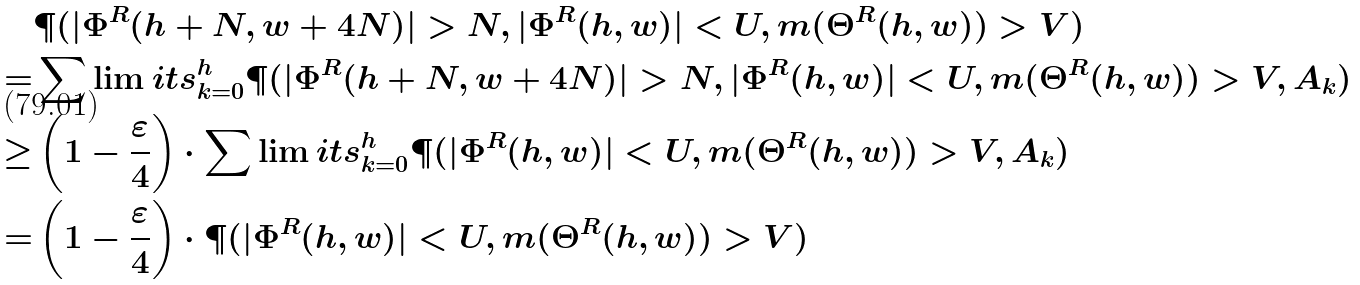<formula> <loc_0><loc_0><loc_500><loc_500>& \P ( | \Phi ^ { R } ( h + N , w + 4 N ) | > N , | \Phi ^ { R } ( h , w ) | < U , m ( \Theta ^ { R } ( h , w ) ) > V ) \\ = & \sum \lim i t s _ { k = 0 } ^ { h } \P ( | \Phi ^ { R } ( h + N , w + 4 N ) | > N , | \Phi ^ { R } ( h , w ) | < U , m ( \Theta ^ { R } ( h , w ) ) > V , A _ { k } ) \\ \geq & \left ( 1 - \frac { \varepsilon } { 4 } \right ) \cdot \sum \lim i t s _ { k = 0 } ^ { h } \P ( | \Phi ^ { R } ( h , w ) | < U , m ( \Theta ^ { R } ( h , w ) ) > V , A _ { k } ) \\ = & \left ( 1 - \frac { \varepsilon } { 4 } \right ) \cdot \P ( | \Phi ^ { R } ( h , w ) | < U , m ( \Theta ^ { R } ( h , w ) ) > V )</formula> 